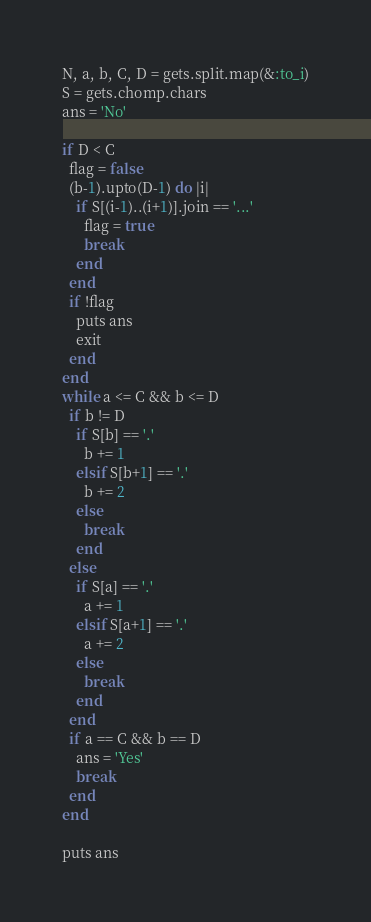<code> <loc_0><loc_0><loc_500><loc_500><_Ruby_>N, a, b, C, D = gets.split.map(&:to_i)
S = gets.chomp.chars
ans = 'No'

if D < C
  flag = false
  (b-1).upto(D-1) do |i|
    if S[(i-1)..(i+1)].join == '...'
      flag = true
      break
    end
  end
  if !flag
    puts ans
    exit
  end
end
while a <= C && b <= D
  if b != D
    if S[b] == '.'
      b += 1
    elsif S[b+1] == '.'
      b += 2
    else
      break
    end
  else
    if S[a] == '.'
      a += 1
    elsif S[a+1] == '.'
      a += 2
    else
      break
    end
  end
  if a == C && b == D
    ans = 'Yes'
    break
  end
end

puts ans</code> 